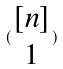<formula> <loc_0><loc_0><loc_500><loc_500>( \begin{matrix} [ n ] \\ 1 \end{matrix} )</formula> 